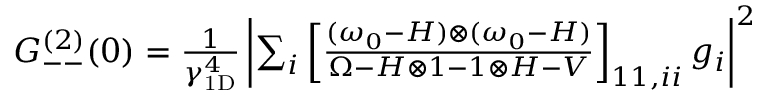Convert formula to latex. <formula><loc_0><loc_0><loc_500><loc_500>\begin{array} { r } { G _ { - - } ^ { ( 2 ) } ( 0 ) = \frac { 1 } \gamma _ { 1 D } ^ { 4 } } \left | \sum _ { i } \left [ \frac { ( \omega _ { 0 } - H ) \otimes ( \omega _ { 0 } - H ) } { \Omega - H \otimes 1 - 1 \otimes H - V } \right ] _ { 1 1 , i i } g _ { i } \right | ^ { 2 } } \end{array}</formula> 